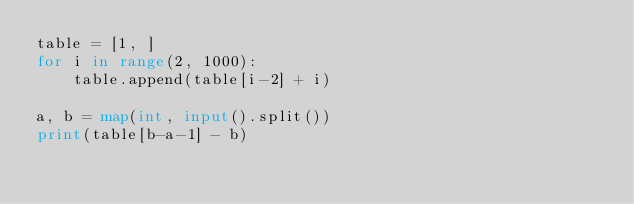Convert code to text. <code><loc_0><loc_0><loc_500><loc_500><_Python_>table = [1, ]
for i in range(2, 1000):
    table.append(table[i-2] + i)

a, b = map(int, input().split())
print(table[b-a-1] - b)</code> 